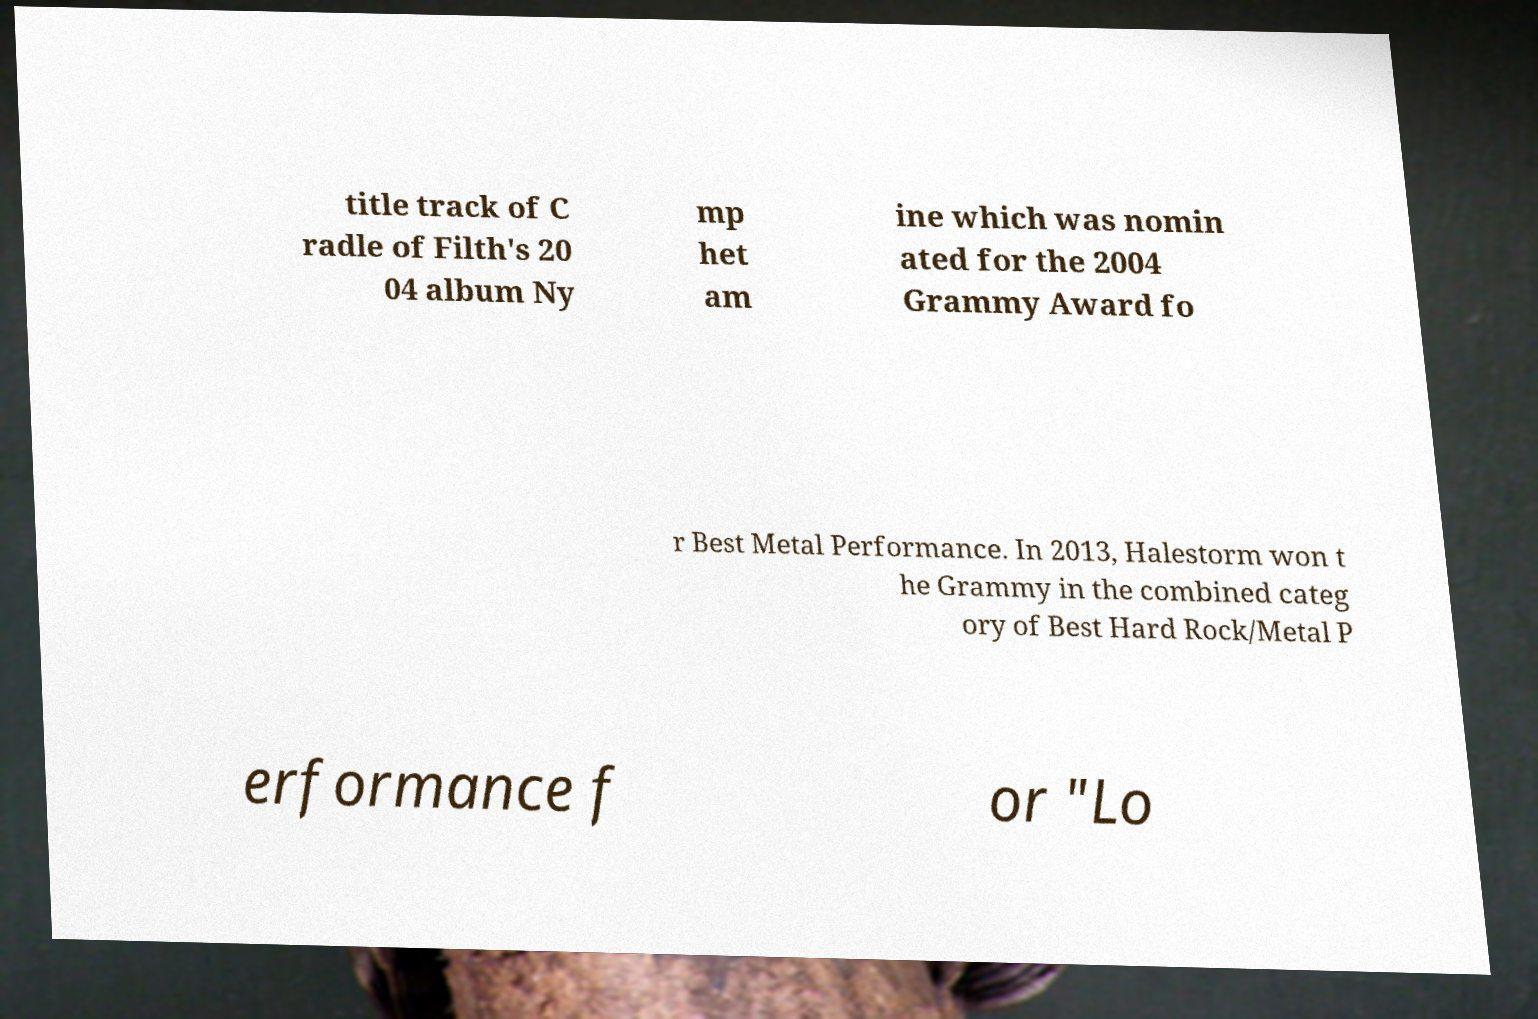I need the written content from this picture converted into text. Can you do that? title track of C radle of Filth's 20 04 album Ny mp het am ine which was nomin ated for the 2004 Grammy Award fo r Best Metal Performance. In 2013, Halestorm won t he Grammy in the combined categ ory of Best Hard Rock/Metal P erformance f or "Lo 